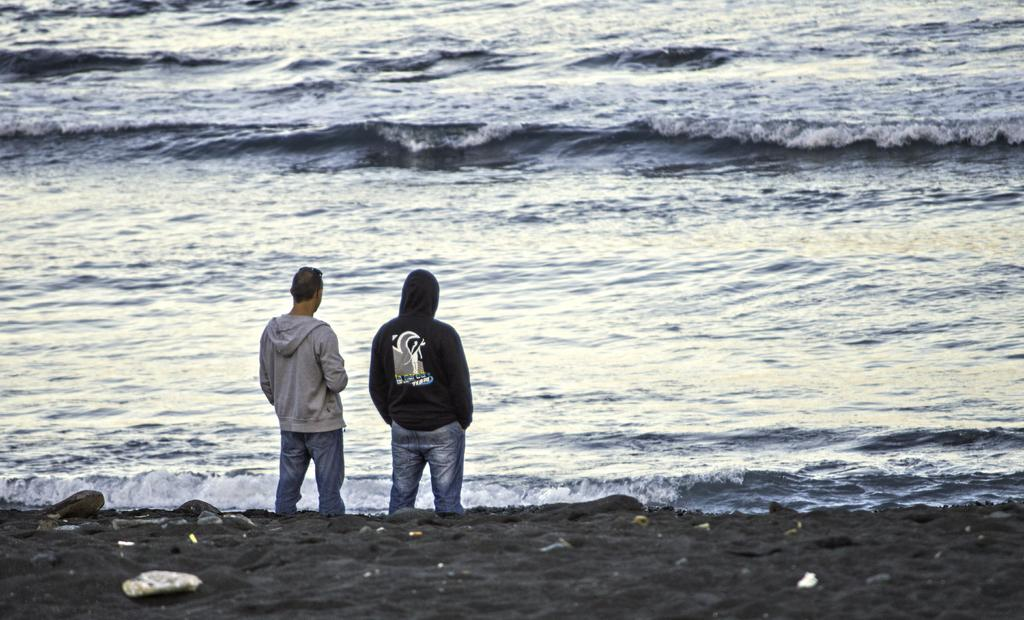How many people are in the image? There are two people in the image. What is the background of the image? The people are standing in front of a sea, and the location is on the sea shore. What are the people wearing? Both people are wearing sweaters. How many cakes are being created by the people in the image? There are no cakes present in the image, and the people are not creating any cakes. 